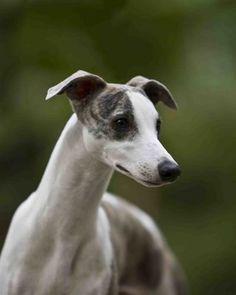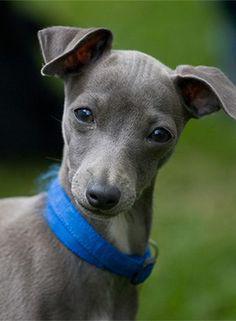The first image is the image on the left, the second image is the image on the right. For the images displayed, is the sentence "The dog in the image on the right is standing in profile with its head turned toward the camera." factually correct? Answer yes or no. Yes. 